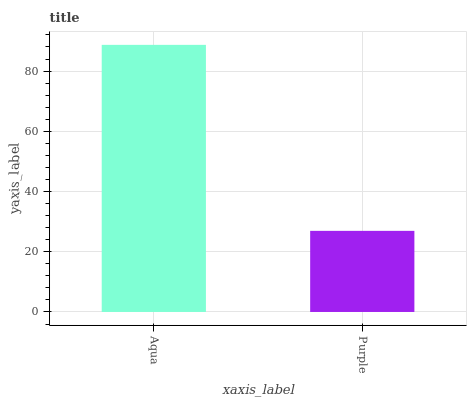Is Purple the minimum?
Answer yes or no. Yes. Is Aqua the maximum?
Answer yes or no. Yes. Is Purple the maximum?
Answer yes or no. No. Is Aqua greater than Purple?
Answer yes or no. Yes. Is Purple less than Aqua?
Answer yes or no. Yes. Is Purple greater than Aqua?
Answer yes or no. No. Is Aqua less than Purple?
Answer yes or no. No. Is Aqua the high median?
Answer yes or no. Yes. Is Purple the low median?
Answer yes or no. Yes. Is Purple the high median?
Answer yes or no. No. Is Aqua the low median?
Answer yes or no. No. 